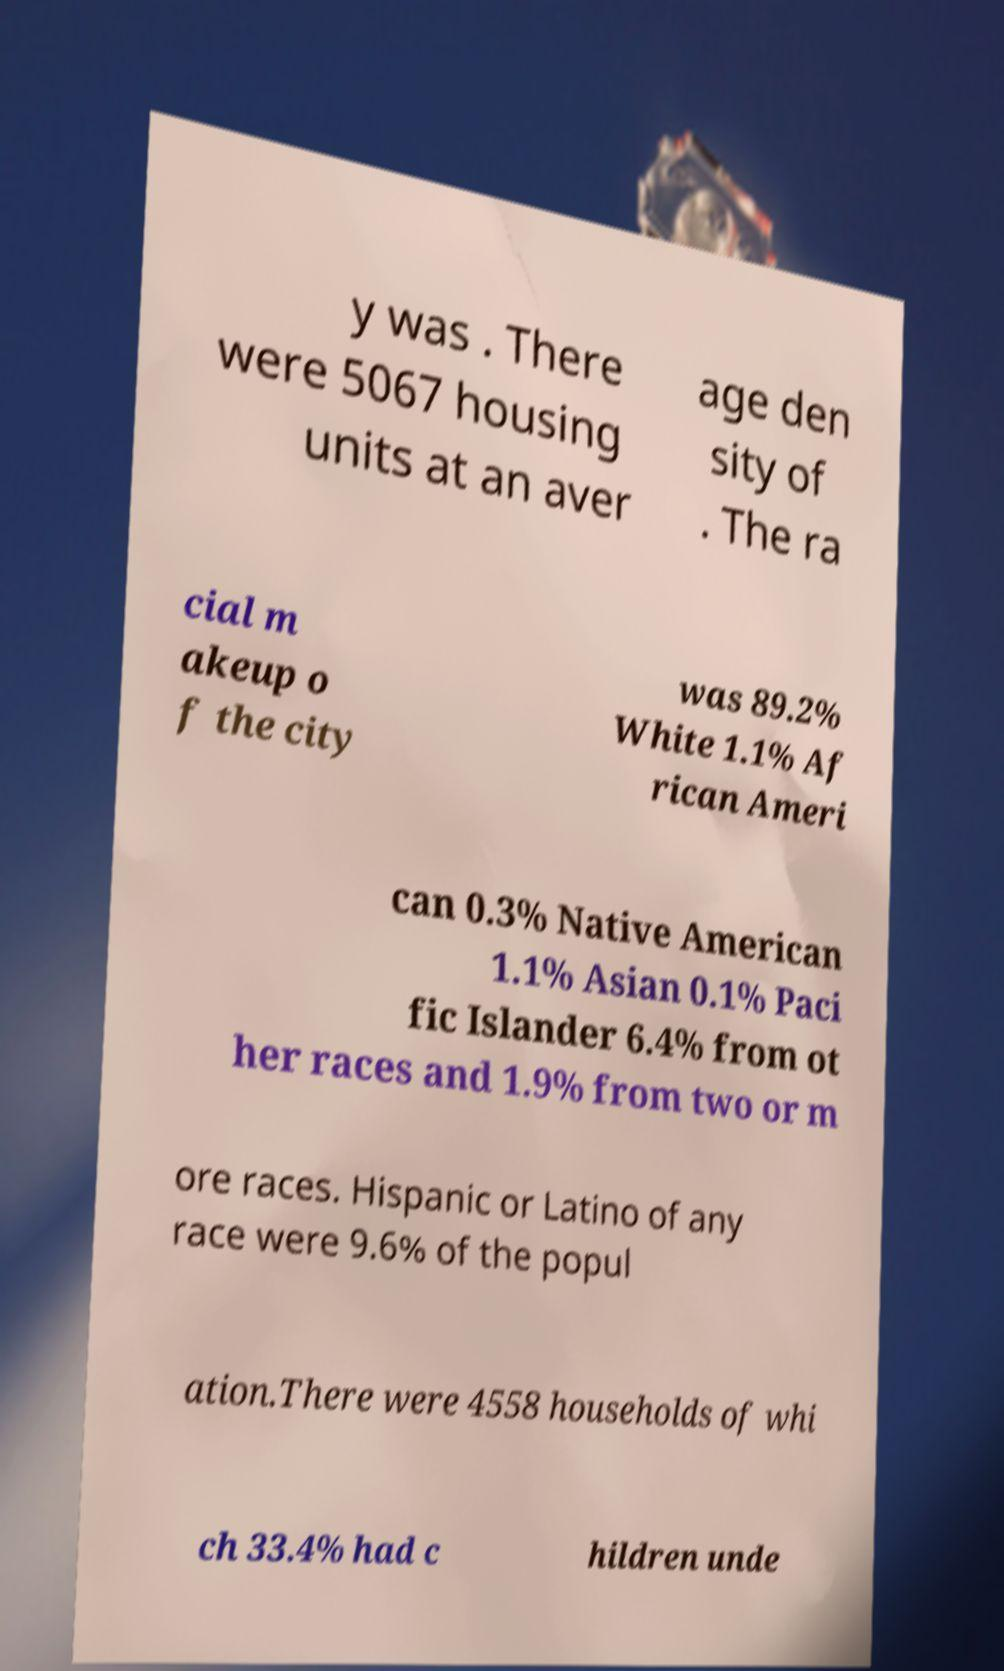Please read and relay the text visible in this image. What does it say? y was . There were 5067 housing units at an aver age den sity of . The ra cial m akeup o f the city was 89.2% White 1.1% Af rican Ameri can 0.3% Native American 1.1% Asian 0.1% Paci fic Islander 6.4% from ot her races and 1.9% from two or m ore races. Hispanic or Latino of any race were 9.6% of the popul ation.There were 4558 households of whi ch 33.4% had c hildren unde 